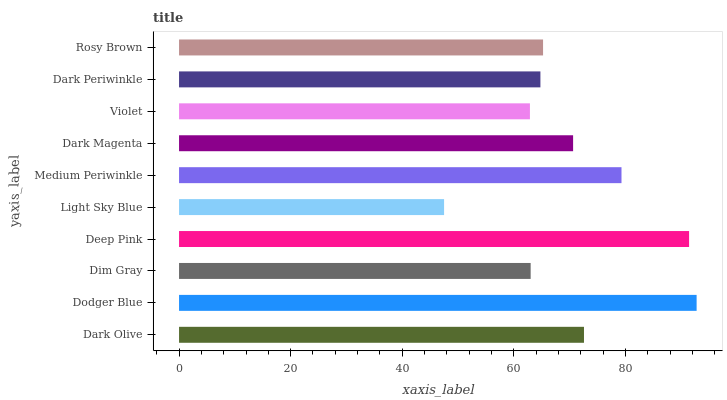Is Light Sky Blue the minimum?
Answer yes or no. Yes. Is Dodger Blue the maximum?
Answer yes or no. Yes. Is Dim Gray the minimum?
Answer yes or no. No. Is Dim Gray the maximum?
Answer yes or no. No. Is Dodger Blue greater than Dim Gray?
Answer yes or no. Yes. Is Dim Gray less than Dodger Blue?
Answer yes or no. Yes. Is Dim Gray greater than Dodger Blue?
Answer yes or no. No. Is Dodger Blue less than Dim Gray?
Answer yes or no. No. Is Dark Magenta the high median?
Answer yes or no. Yes. Is Rosy Brown the low median?
Answer yes or no. Yes. Is Medium Periwinkle the high median?
Answer yes or no. No. Is Dark Periwinkle the low median?
Answer yes or no. No. 